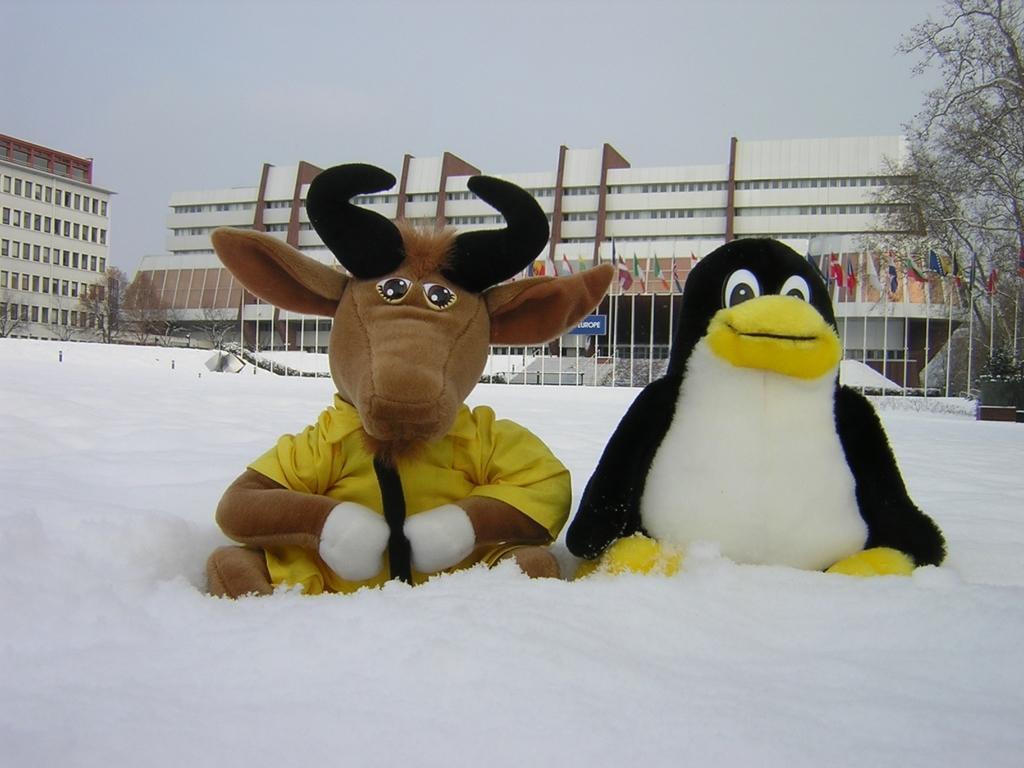How would you summarize this image in a sentence or two? In this image in front there is a depiction of a bull and penguin. At the bottom there is snow on the surface. In the background there are buildings, trees, flags and sky. We can see in front of the building there is a blue board. 